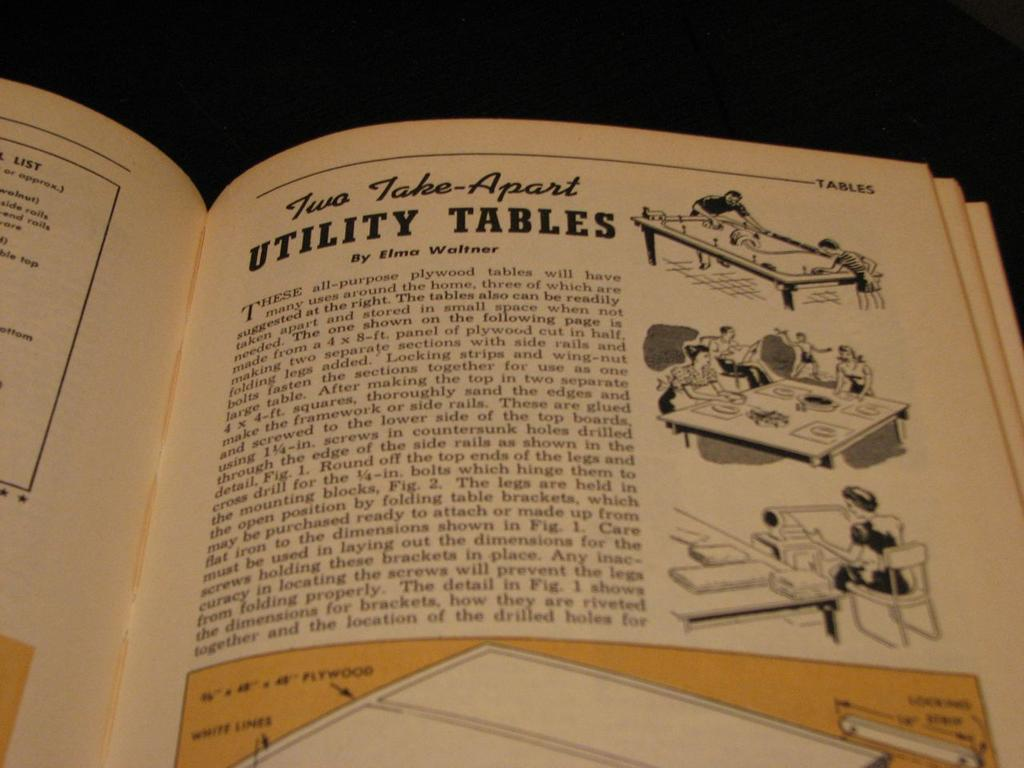Provide a one-sentence caption for the provided image. A book is open to the chapter " Two Take-Apart Utility Tables". 